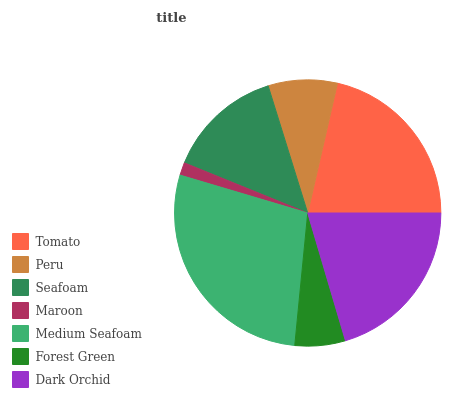Is Maroon the minimum?
Answer yes or no. Yes. Is Medium Seafoam the maximum?
Answer yes or no. Yes. Is Peru the minimum?
Answer yes or no. No. Is Peru the maximum?
Answer yes or no. No. Is Tomato greater than Peru?
Answer yes or no. Yes. Is Peru less than Tomato?
Answer yes or no. Yes. Is Peru greater than Tomato?
Answer yes or no. No. Is Tomato less than Peru?
Answer yes or no. No. Is Seafoam the high median?
Answer yes or no. Yes. Is Seafoam the low median?
Answer yes or no. Yes. Is Forest Green the high median?
Answer yes or no. No. Is Tomato the low median?
Answer yes or no. No. 